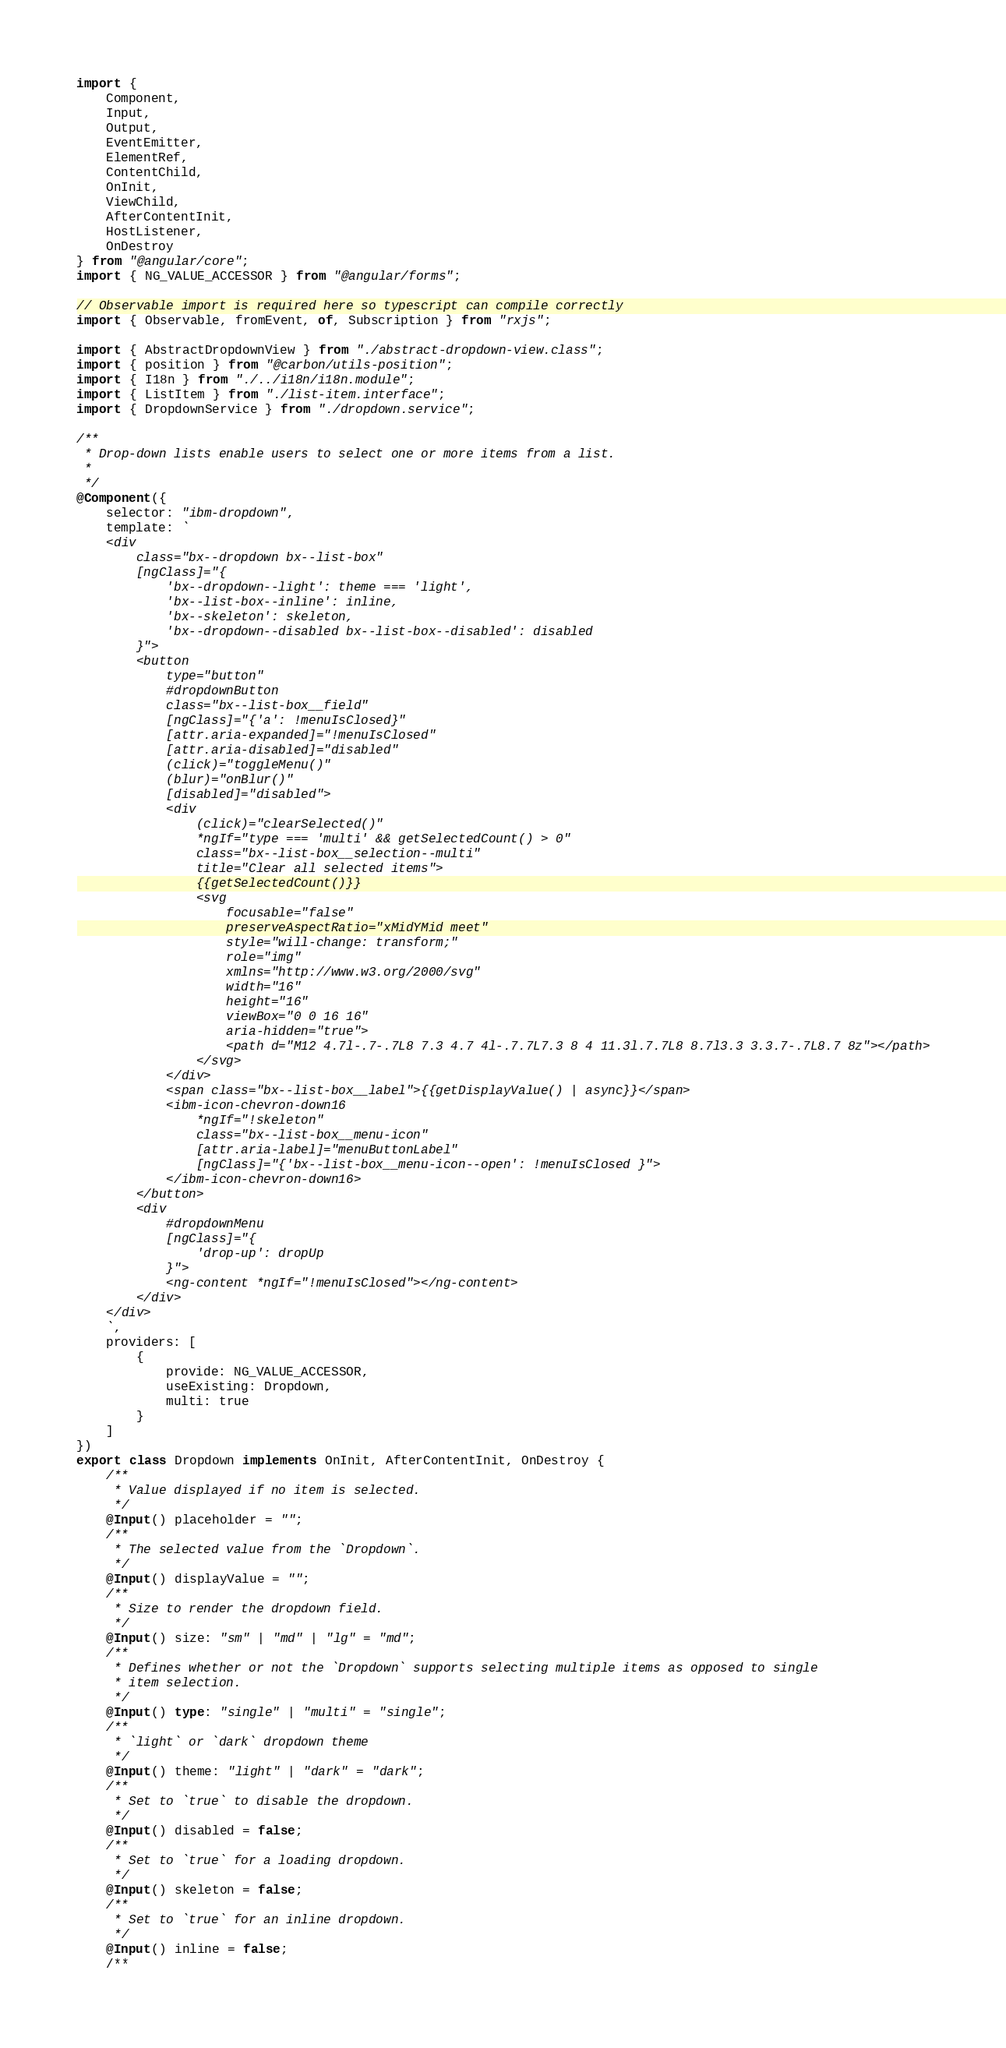<code> <loc_0><loc_0><loc_500><loc_500><_TypeScript_>import {
	Component,
	Input,
	Output,
	EventEmitter,
	ElementRef,
	ContentChild,
	OnInit,
	ViewChild,
	AfterContentInit,
	HostListener,
	OnDestroy
} from "@angular/core";
import { NG_VALUE_ACCESSOR } from "@angular/forms";

// Observable import is required here so typescript can compile correctly
import { Observable, fromEvent, of, Subscription } from "rxjs";

import { AbstractDropdownView } from "./abstract-dropdown-view.class";
import { position } from "@carbon/utils-position";
import { I18n } from "./../i18n/i18n.module";
import { ListItem } from "./list-item.interface";
import { DropdownService } from "./dropdown.service";

/**
 * Drop-down lists enable users to select one or more items from a list.
 *
 */
@Component({
	selector: "ibm-dropdown",
	template: `
	<div
		class="bx--dropdown bx--list-box"
		[ngClass]="{
			'bx--dropdown--light': theme === 'light',
			'bx--list-box--inline': inline,
			'bx--skeleton': skeleton,
			'bx--dropdown--disabled bx--list-box--disabled': disabled
		}">
		<button
			type="button"
			#dropdownButton
			class="bx--list-box__field"
			[ngClass]="{'a': !menuIsClosed}"
			[attr.aria-expanded]="!menuIsClosed"
			[attr.aria-disabled]="disabled"
			(click)="toggleMenu()"
			(blur)="onBlur()"
			[disabled]="disabled">
			<div
				(click)="clearSelected()"
				*ngIf="type === 'multi' && getSelectedCount() > 0"
				class="bx--list-box__selection--multi"
				title="Clear all selected items">
				{{getSelectedCount()}}
				<svg
					focusable="false"
					preserveAspectRatio="xMidYMid meet"
					style="will-change: transform;"
					role="img"
					xmlns="http://www.w3.org/2000/svg"
					width="16"
					height="16"
					viewBox="0 0 16 16"
					aria-hidden="true">
					<path d="M12 4.7l-.7-.7L8 7.3 4.7 4l-.7.7L7.3 8 4 11.3l.7.7L8 8.7l3.3 3.3.7-.7L8.7 8z"></path>
				</svg>
			</div>
			<span class="bx--list-box__label">{{getDisplayValue() | async}}</span>
			<ibm-icon-chevron-down16
				*ngIf="!skeleton"
				class="bx--list-box__menu-icon"
				[attr.aria-label]="menuButtonLabel"
				[ngClass]="{'bx--list-box__menu-icon--open': !menuIsClosed }">
			</ibm-icon-chevron-down16>
		</button>
		<div
			#dropdownMenu
			[ngClass]="{
				'drop-up': dropUp
			}">
			<ng-content *ngIf="!menuIsClosed"></ng-content>
		</div>
	</div>
	`,
	providers: [
		{
			provide: NG_VALUE_ACCESSOR,
			useExisting: Dropdown,
			multi: true
		}
	]
})
export class Dropdown implements OnInit, AfterContentInit, OnDestroy {
	/**
	 * Value displayed if no item is selected.
	 */
	@Input() placeholder = "";
	/**
	 * The selected value from the `Dropdown`.
	 */
	@Input() displayValue = "";
	/**
	 * Size to render the dropdown field.
	 */
	@Input() size: "sm" | "md" | "lg" = "md";
	/**
	 * Defines whether or not the `Dropdown` supports selecting multiple items as opposed to single
	 * item selection.
	 */
	@Input() type: "single" | "multi" = "single";
	/**
	 * `light` or `dark` dropdown theme
	 */
	@Input() theme: "light" | "dark" = "dark";
	/**
	 * Set to `true` to disable the dropdown.
	 */
	@Input() disabled = false;
	/**
	 * Set to `true` for a loading dropdown.
	 */
	@Input() skeleton = false;
	/**
	 * Set to `true` for an inline dropdown.
	 */
	@Input() inline = false;
	/**</code> 